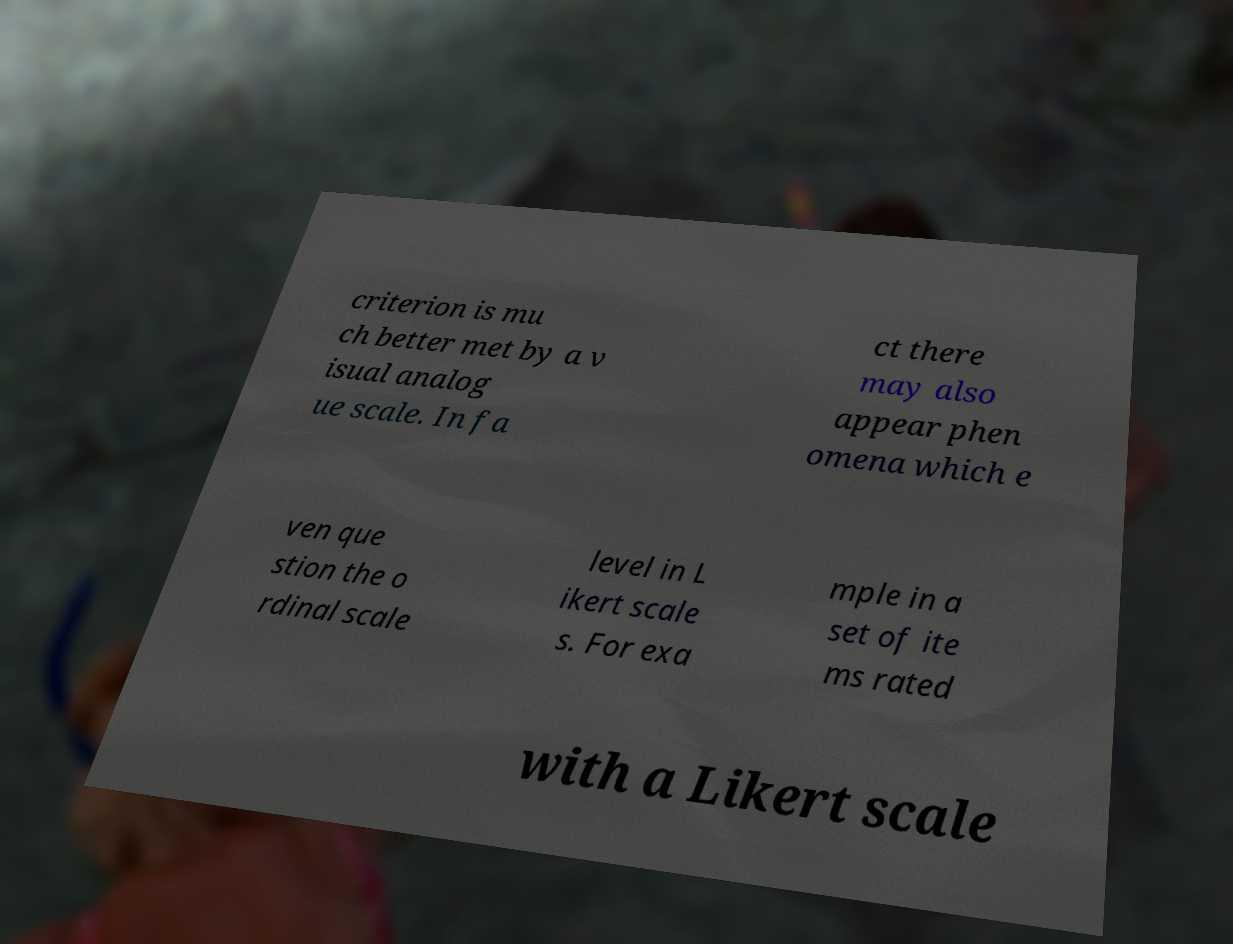I need the written content from this picture converted into text. Can you do that? criterion is mu ch better met by a v isual analog ue scale. In fa ct there may also appear phen omena which e ven que stion the o rdinal scale level in L ikert scale s. For exa mple in a set of ite ms rated with a Likert scale 